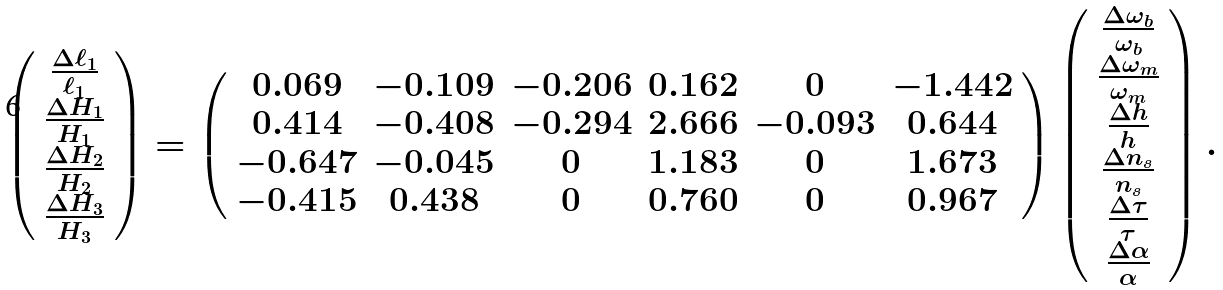Convert formula to latex. <formula><loc_0><loc_0><loc_500><loc_500>\left ( \begin{array} { c } \frac { \Delta \ell _ { 1 } } { \ell _ { 1 } } \\ \frac { \Delta H _ { 1 } } { H _ { 1 } } \\ \frac { \Delta H _ { 2 } } { H _ { 2 } } \\ \frac { \Delta H _ { 3 } } { H _ { 3 } } \end{array} \right ) = \left ( \begin{array} { c c c c c c } 0 . 0 6 9 & - 0 . 1 0 9 & - 0 . 2 0 6 & 0 . 1 6 2 & 0 & - 1 . 4 4 2 \\ 0 . 4 1 4 & - 0 . 4 0 8 & - 0 . 2 9 4 & 2 . 6 6 6 & - 0 . 0 9 3 & 0 . 6 4 4 \\ - 0 . 6 4 7 & - 0 . 0 4 5 & 0 & 1 . 1 8 3 & 0 & 1 . 6 7 3 \\ - 0 . 4 1 5 & 0 . 4 3 8 & 0 & 0 . 7 6 0 & 0 & 0 . 9 6 7 \end{array} \right ) \left ( \begin{array} { c } \frac { \Delta \omega _ { b } } { \omega _ { b } } \\ \frac { \Delta \omega _ { m } } { \omega _ { m } } \\ \frac { \Delta h } { h } \\ \frac { \Delta n _ { s } } { n _ { s } } \\ \frac { \Delta \tau } { \tau } \\ \frac { \Delta \alpha } { \alpha } \end{array} \right ) .</formula> 